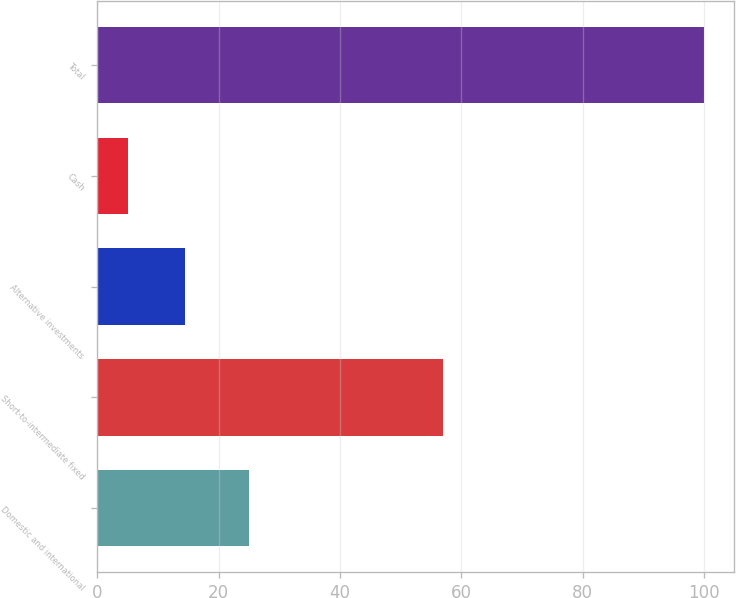Convert chart. <chart><loc_0><loc_0><loc_500><loc_500><bar_chart><fcel>Domestic and international<fcel>Short-to-intermediate fixed<fcel>Alternative investments<fcel>Cash<fcel>Total<nl><fcel>25<fcel>57<fcel>14.5<fcel>5<fcel>100<nl></chart> 